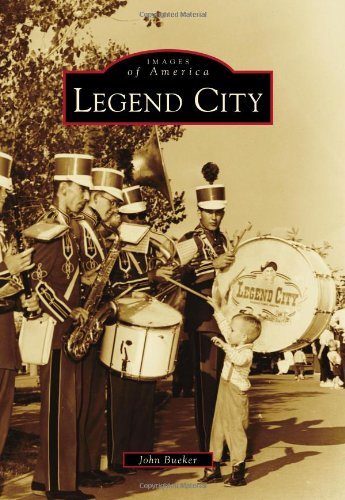Can you point out the historical significance of the scene depicted on this book's cover? The cover photo, featuring a marching band and a child interacting with them, encapsulates a vibrant slice of mid-20th century Americana, often idealized in depictions of community and public celebration in theme parks like Legend City. 